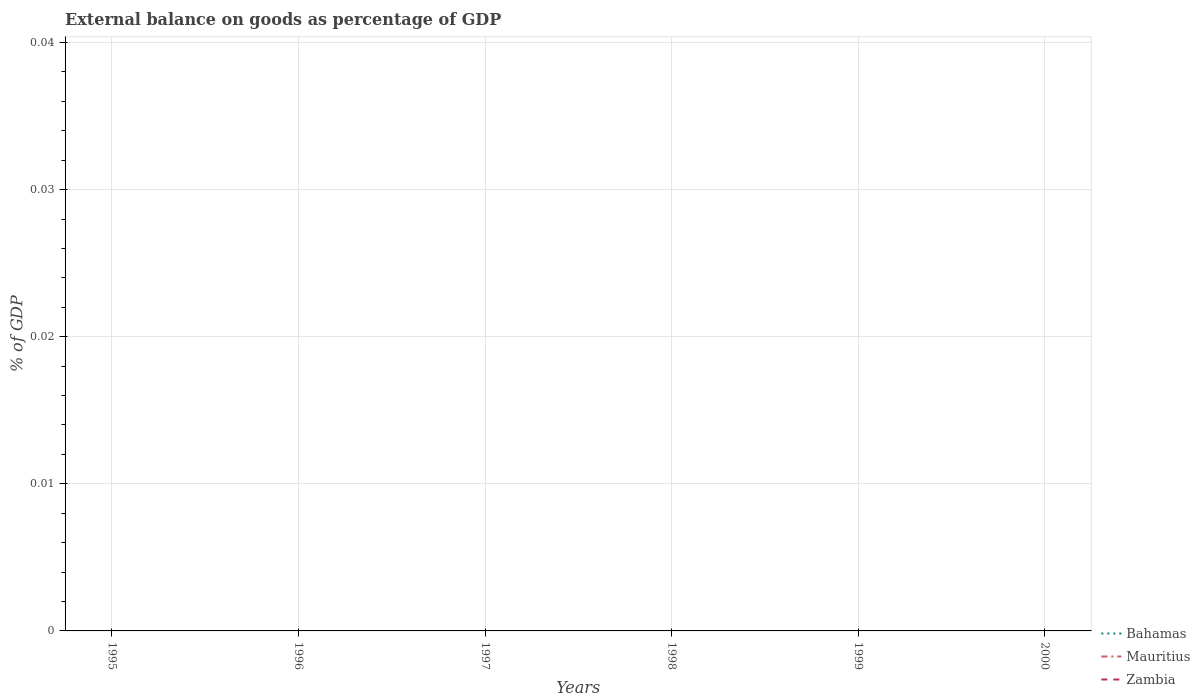How many different coloured lines are there?
Offer a very short reply. 0. Does the line corresponding to Zambia intersect with the line corresponding to Mauritius?
Ensure brevity in your answer.  Yes. Is the number of lines equal to the number of legend labels?
Your answer should be very brief. No. Across all years, what is the maximum external balance on goods as percentage of GDP in Mauritius?
Ensure brevity in your answer.  0. Is the external balance on goods as percentage of GDP in Bahamas strictly greater than the external balance on goods as percentage of GDP in Zambia over the years?
Make the answer very short. No. What is the difference between two consecutive major ticks on the Y-axis?
Provide a short and direct response. 0.01. Does the graph contain any zero values?
Provide a short and direct response. Yes. Does the graph contain grids?
Your answer should be very brief. Yes. How are the legend labels stacked?
Your answer should be compact. Vertical. What is the title of the graph?
Your answer should be very brief. External balance on goods as percentage of GDP. What is the label or title of the X-axis?
Your answer should be compact. Years. What is the label or title of the Y-axis?
Provide a succinct answer. % of GDP. What is the % of GDP of Bahamas in 1995?
Make the answer very short. 0. What is the % of GDP of Zambia in 1995?
Make the answer very short. 0. What is the % of GDP of Bahamas in 1996?
Your response must be concise. 0. What is the % of GDP of Mauritius in 1996?
Keep it short and to the point. 0. What is the % of GDP of Zambia in 1996?
Give a very brief answer. 0. What is the % of GDP in Bahamas in 1997?
Offer a terse response. 0. What is the % of GDP in Mauritius in 1997?
Your answer should be very brief. 0. What is the % of GDP of Zambia in 1997?
Offer a terse response. 0. What is the % of GDP of Bahamas in 1998?
Ensure brevity in your answer.  0. What is the % of GDP in Zambia in 1998?
Provide a short and direct response. 0. What is the % of GDP in Mauritius in 1999?
Your answer should be very brief. 0. What is the % of GDP of Zambia in 1999?
Provide a short and direct response. 0. What is the % of GDP of Bahamas in 2000?
Give a very brief answer. 0. What is the % of GDP of Mauritius in 2000?
Offer a terse response. 0. What is the % of GDP in Zambia in 2000?
Keep it short and to the point. 0. What is the total % of GDP in Zambia in the graph?
Your answer should be compact. 0. What is the average % of GDP in Bahamas per year?
Offer a terse response. 0. What is the average % of GDP in Mauritius per year?
Offer a very short reply. 0. 